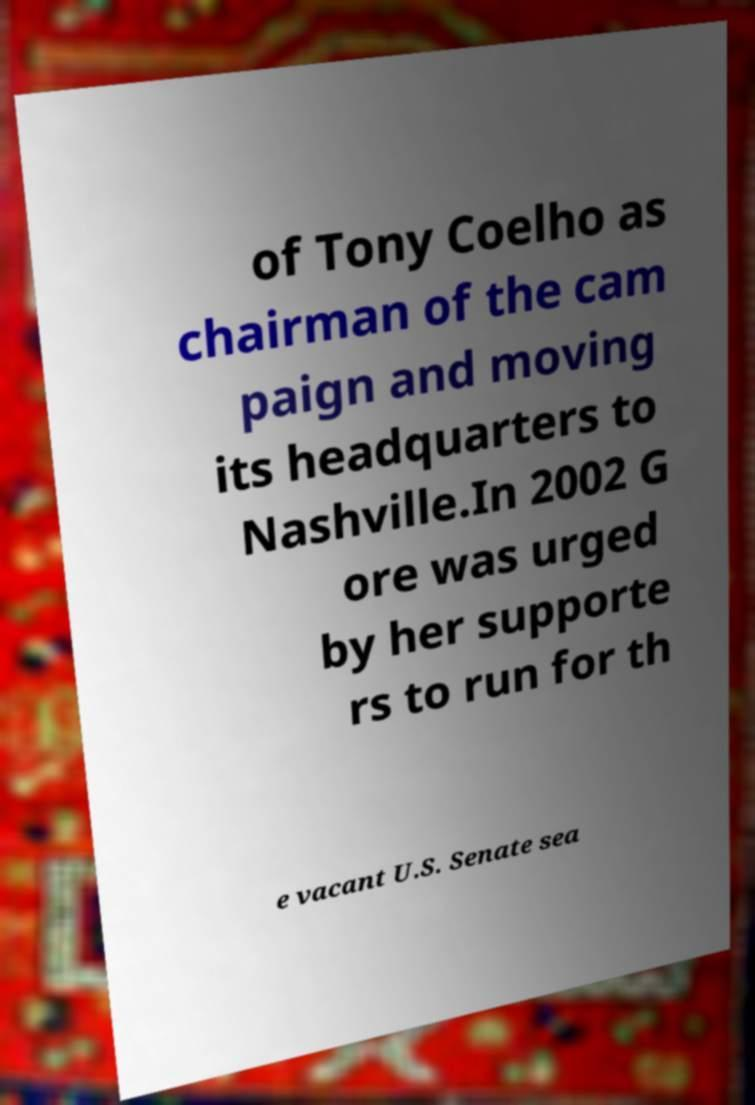Could you extract and type out the text from this image? of Tony Coelho as chairman of the cam paign and moving its headquarters to Nashville.In 2002 G ore was urged by her supporte rs to run for th e vacant U.S. Senate sea 